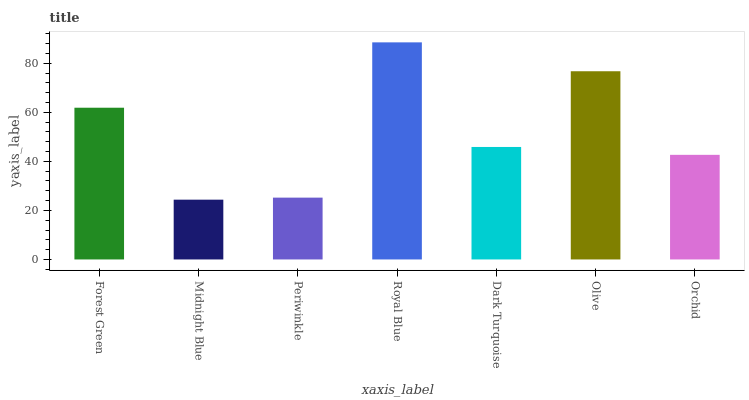Is Midnight Blue the minimum?
Answer yes or no. Yes. Is Royal Blue the maximum?
Answer yes or no. Yes. Is Periwinkle the minimum?
Answer yes or no. No. Is Periwinkle the maximum?
Answer yes or no. No. Is Periwinkle greater than Midnight Blue?
Answer yes or no. Yes. Is Midnight Blue less than Periwinkle?
Answer yes or no. Yes. Is Midnight Blue greater than Periwinkle?
Answer yes or no. No. Is Periwinkle less than Midnight Blue?
Answer yes or no. No. Is Dark Turquoise the high median?
Answer yes or no. Yes. Is Dark Turquoise the low median?
Answer yes or no. Yes. Is Forest Green the high median?
Answer yes or no. No. Is Forest Green the low median?
Answer yes or no. No. 